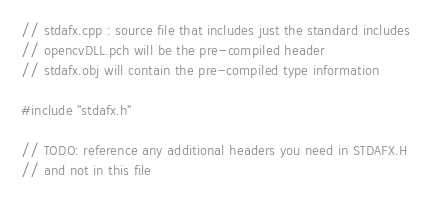<code> <loc_0><loc_0><loc_500><loc_500><_C++_>// stdafx.cpp : source file that includes just the standard includes
// opencvDLL.pch will be the pre-compiled header
// stdafx.obj will contain the pre-compiled type information

#include "stdafx.h"

// TODO: reference any additional headers you need in STDAFX.H
// and not in this file
</code> 